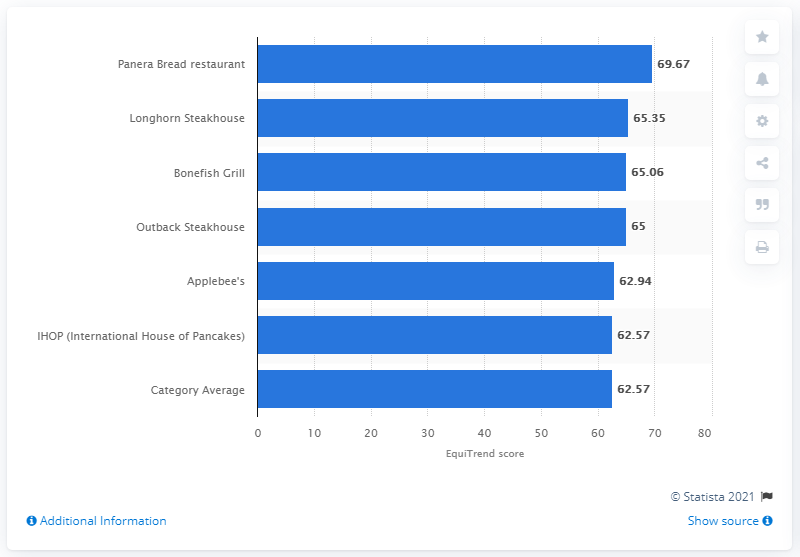Mention a couple of crucial points in this snapshot. In 2012, Panera Bread received a EquiTrend score of 69.67, which indicates a high level of brand recognition and customer satisfaction. 